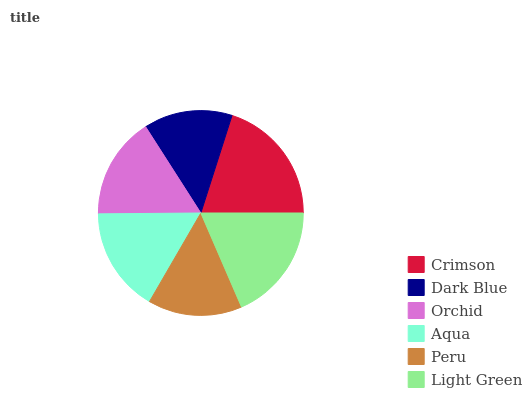Is Dark Blue the minimum?
Answer yes or no. Yes. Is Crimson the maximum?
Answer yes or no. Yes. Is Orchid the minimum?
Answer yes or no. No. Is Orchid the maximum?
Answer yes or no. No. Is Orchid greater than Dark Blue?
Answer yes or no. Yes. Is Dark Blue less than Orchid?
Answer yes or no. Yes. Is Dark Blue greater than Orchid?
Answer yes or no. No. Is Orchid less than Dark Blue?
Answer yes or no. No. Is Aqua the high median?
Answer yes or no. Yes. Is Orchid the low median?
Answer yes or no. Yes. Is Crimson the high median?
Answer yes or no. No. Is Aqua the low median?
Answer yes or no. No. 